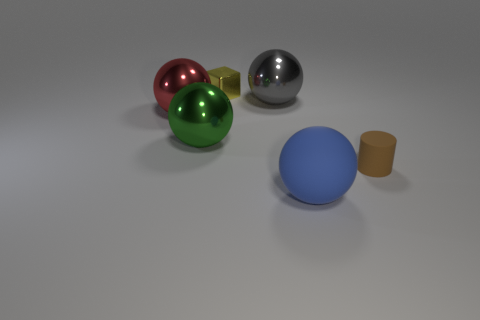What can be inferred about the texture of the green sphere? The green sphere has a smooth and reflective surface texture, suggesting it is also made of a metallic or polished material. The reflection and sheen give it a tactile quality that implies it would be cool and slick to the touch. 